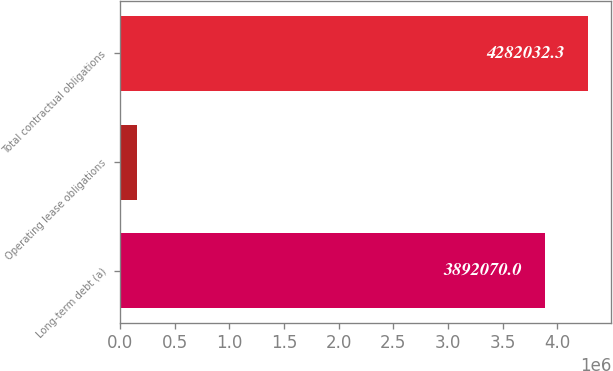Convert chart to OTSL. <chart><loc_0><loc_0><loc_500><loc_500><bar_chart><fcel>Long-term debt (a)<fcel>Operating lease obligations<fcel>Total contractual obligations<nl><fcel>3.89207e+06<fcel>160808<fcel>4.28203e+06<nl></chart> 